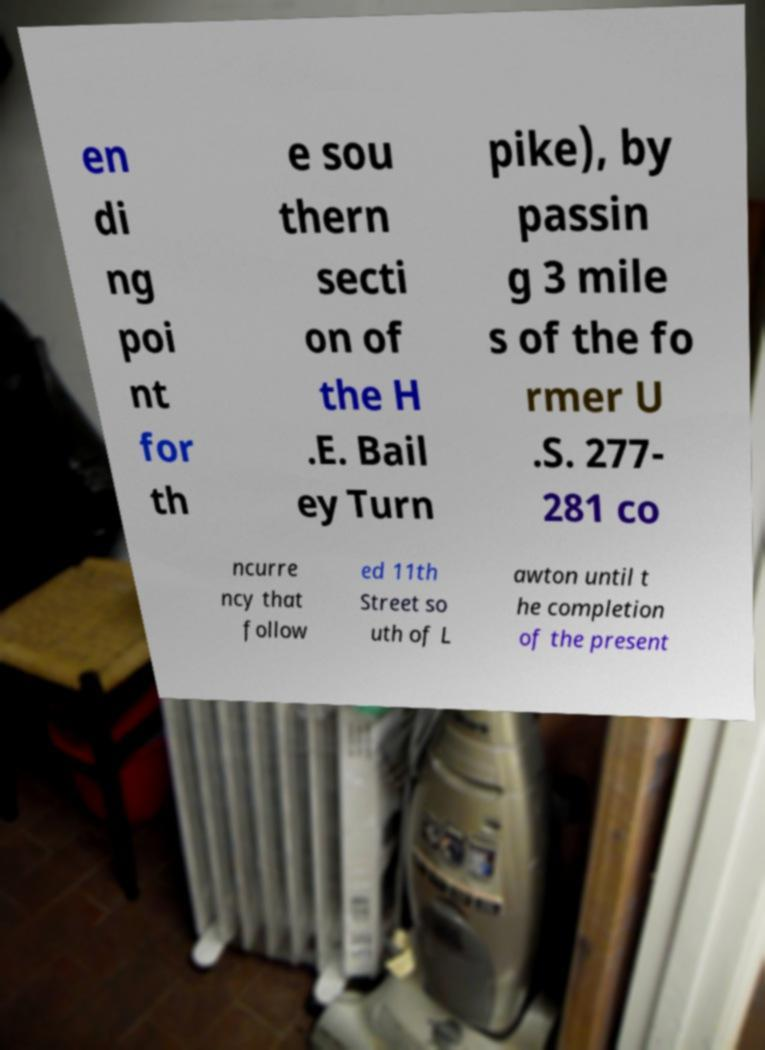Please read and relay the text visible in this image. What does it say? en di ng poi nt for th e sou thern secti on of the H .E. Bail ey Turn pike), by passin g 3 mile s of the fo rmer U .S. 277- 281 co ncurre ncy that follow ed 11th Street so uth of L awton until t he completion of the present 